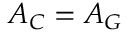Convert formula to latex. <formula><loc_0><loc_0><loc_500><loc_500>A _ { C } = A _ { G }</formula> 